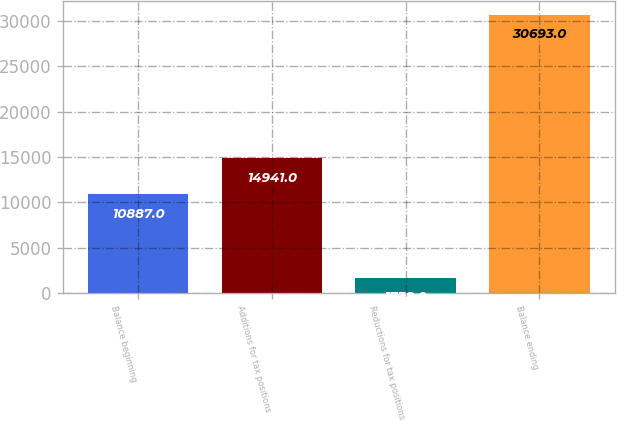<chart> <loc_0><loc_0><loc_500><loc_500><bar_chart><fcel>Balance beginning<fcel>Additions for tax positions<fcel>Reductions for tax positions<fcel>Balance ending<nl><fcel>10887<fcel>14941<fcel>1738<fcel>30693<nl></chart> 